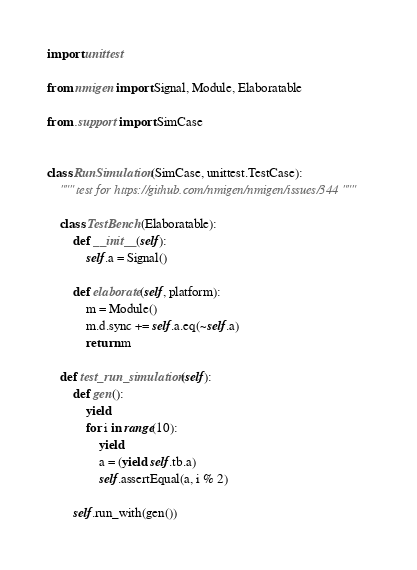<code> <loc_0><loc_0><loc_500><loc_500><_Python_>import unittest

from nmigen import Signal, Module, Elaboratable

from .support import SimCase


class RunSimulation(SimCase, unittest.TestCase):
    """ test for https://github.com/nmigen/nmigen/issues/344 """

    class TestBench(Elaboratable):
        def __init__(self):
            self.a = Signal()

        def elaborate(self, platform):
            m = Module()
            m.d.sync += self.a.eq(~self.a)
            return m

    def test_run_simulation(self):
        def gen():
            yield
            for i in range(10):
                yield
                a = (yield self.tb.a)
                self.assertEqual(a, i % 2)

        self.run_with(gen())
</code> 